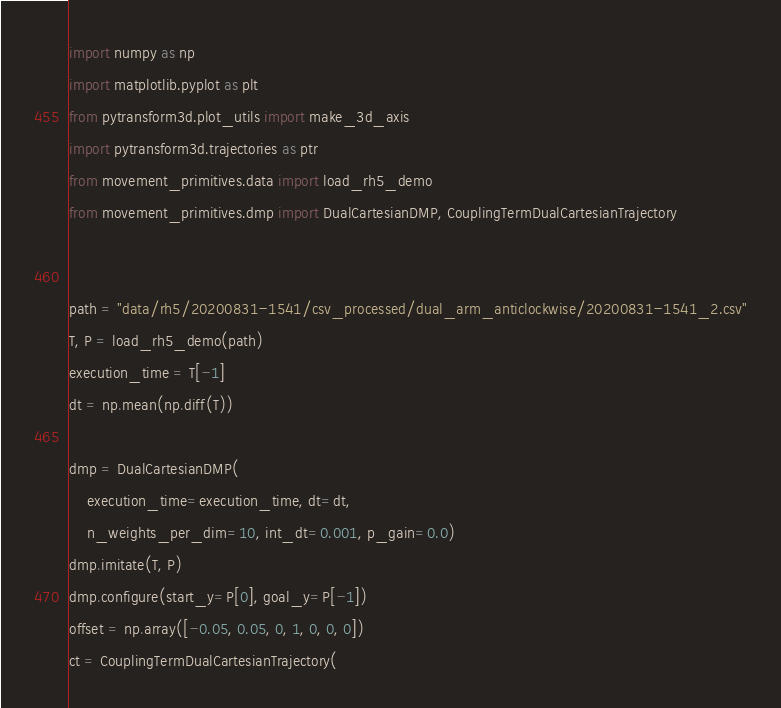<code> <loc_0><loc_0><loc_500><loc_500><_Python_>import numpy as np
import matplotlib.pyplot as plt
from pytransform3d.plot_utils import make_3d_axis
import pytransform3d.trajectories as ptr
from movement_primitives.data import load_rh5_demo
from movement_primitives.dmp import DualCartesianDMP, CouplingTermDualCartesianTrajectory


path = "data/rh5/20200831-1541/csv_processed/dual_arm_anticlockwise/20200831-1541_2.csv"
T, P = load_rh5_demo(path)
execution_time = T[-1]
dt = np.mean(np.diff(T))

dmp = DualCartesianDMP(
    execution_time=execution_time, dt=dt,
    n_weights_per_dim=10, int_dt=0.001, p_gain=0.0)
dmp.imitate(T, P)
dmp.configure(start_y=P[0], goal_y=P[-1])
offset = np.array([-0.05, 0.05, 0, 1, 0, 0, 0])
ct = CouplingTermDualCartesianTrajectory(</code> 